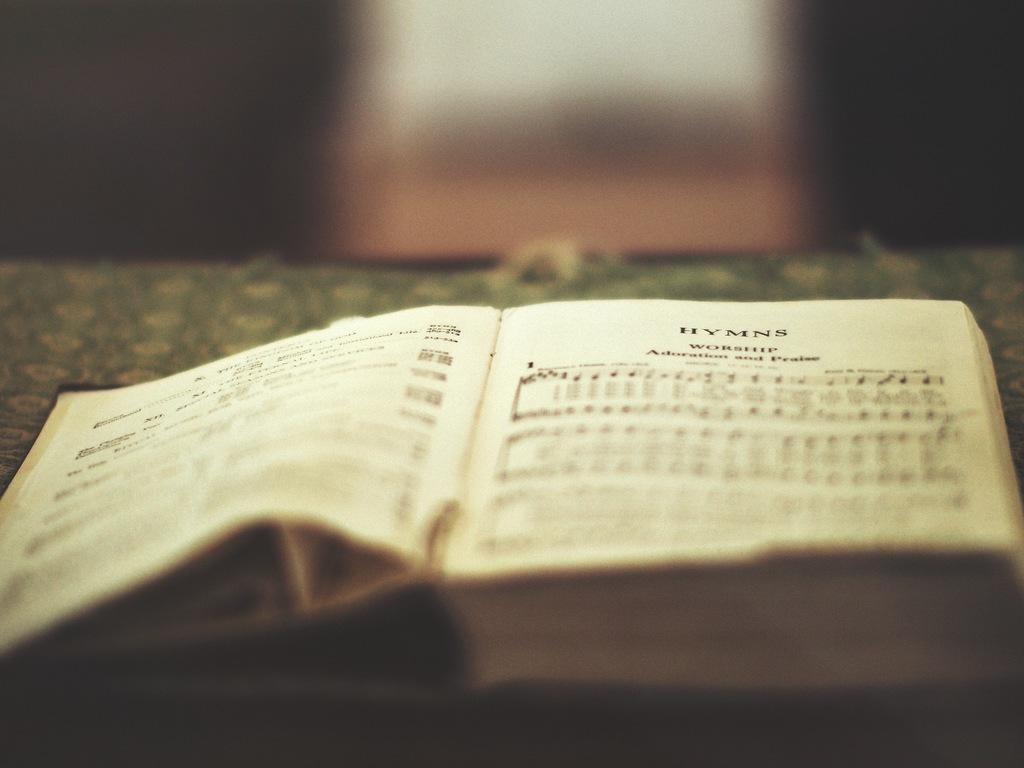What is this book made up of?
Ensure brevity in your answer.  Hymns. These are what?
Ensure brevity in your answer.  Hymns. 